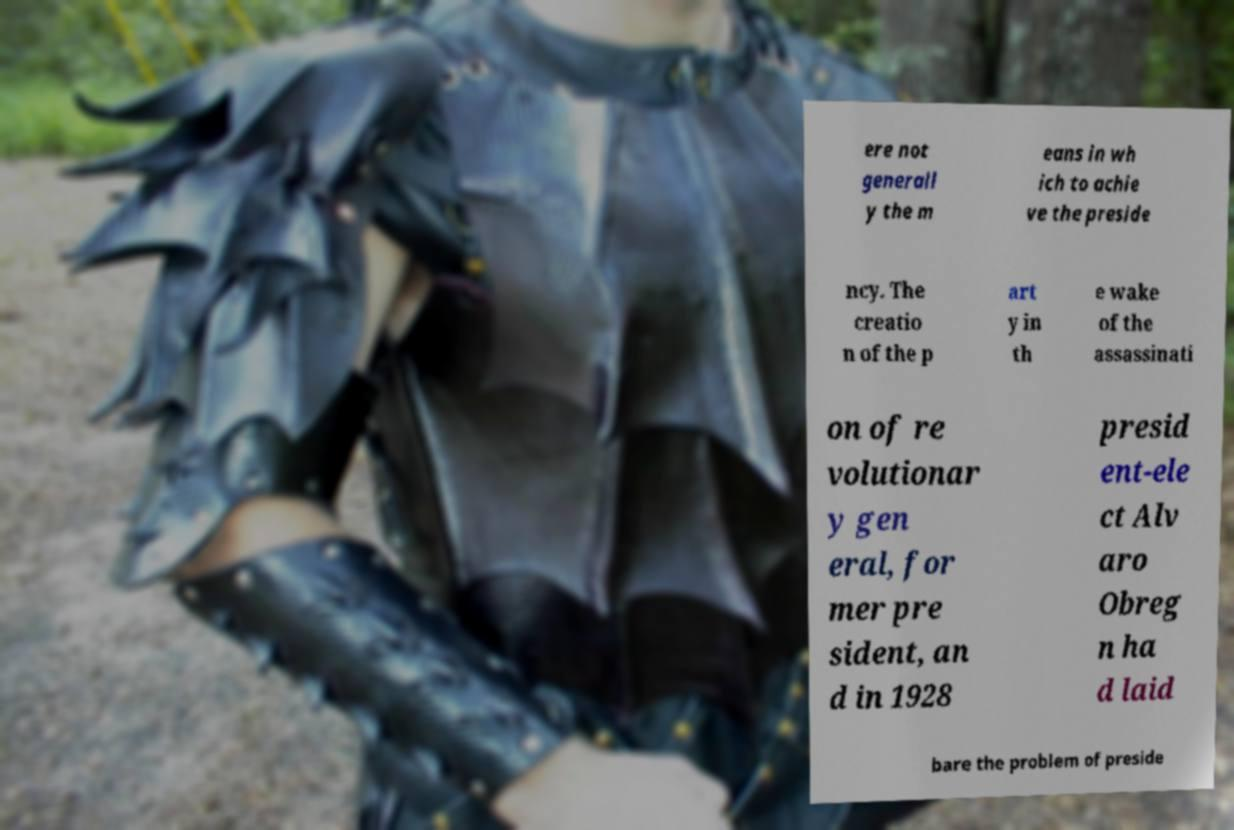Can you read and provide the text displayed in the image?This photo seems to have some interesting text. Can you extract and type it out for me? ere not generall y the m eans in wh ich to achie ve the preside ncy. The creatio n of the p art y in th e wake of the assassinati on of re volutionar y gen eral, for mer pre sident, an d in 1928 presid ent-ele ct Alv aro Obreg n ha d laid bare the problem of preside 